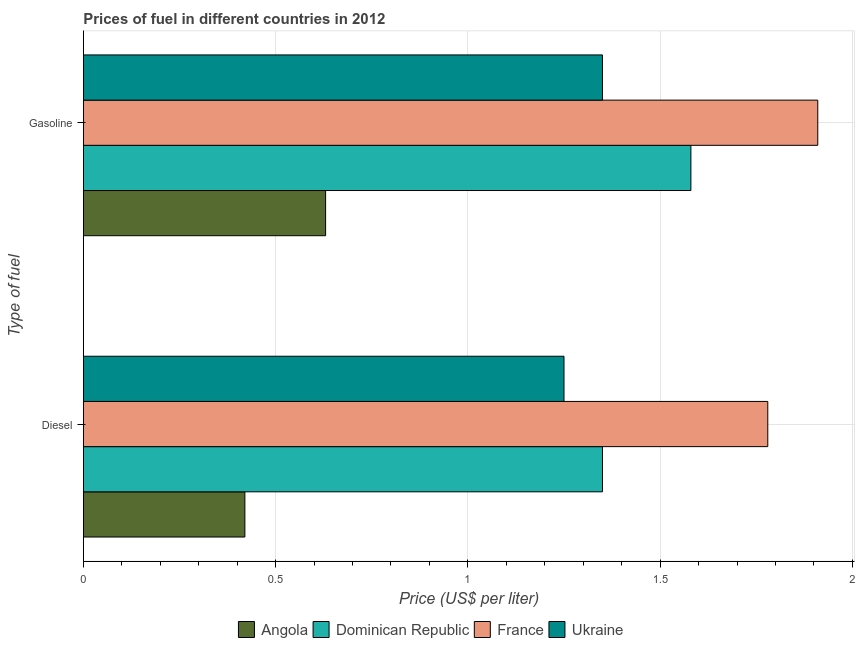How many bars are there on the 1st tick from the bottom?
Provide a short and direct response. 4. What is the label of the 2nd group of bars from the top?
Keep it short and to the point. Diesel. What is the diesel price in Dominican Republic?
Offer a very short reply. 1.35. Across all countries, what is the maximum gasoline price?
Give a very brief answer. 1.91. Across all countries, what is the minimum diesel price?
Provide a short and direct response. 0.42. In which country was the diesel price maximum?
Give a very brief answer. France. In which country was the diesel price minimum?
Give a very brief answer. Angola. What is the difference between the gasoline price in Ukraine and that in France?
Keep it short and to the point. -0.56. What is the difference between the diesel price in France and the gasoline price in Dominican Republic?
Provide a short and direct response. 0.2. What is the difference between the diesel price and gasoline price in France?
Your answer should be very brief. -0.13. In how many countries, is the diesel price greater than 1.4 US$ per litre?
Your answer should be very brief. 1. Is the diesel price in France less than that in Dominican Republic?
Provide a short and direct response. No. What does the 4th bar from the top in Diesel represents?
Your response must be concise. Angola. What does the 4th bar from the bottom in Diesel represents?
Make the answer very short. Ukraine. Are the values on the major ticks of X-axis written in scientific E-notation?
Ensure brevity in your answer.  No. Does the graph contain any zero values?
Give a very brief answer. No. Does the graph contain grids?
Provide a succinct answer. Yes. What is the title of the graph?
Offer a terse response. Prices of fuel in different countries in 2012. What is the label or title of the X-axis?
Provide a succinct answer. Price (US$ per liter). What is the label or title of the Y-axis?
Provide a succinct answer. Type of fuel. What is the Price (US$ per liter) in Angola in Diesel?
Ensure brevity in your answer.  0.42. What is the Price (US$ per liter) in Dominican Republic in Diesel?
Your response must be concise. 1.35. What is the Price (US$ per liter) of France in Diesel?
Offer a terse response. 1.78. What is the Price (US$ per liter) of Angola in Gasoline?
Offer a terse response. 0.63. What is the Price (US$ per liter) in Dominican Republic in Gasoline?
Your response must be concise. 1.58. What is the Price (US$ per liter) of France in Gasoline?
Provide a succinct answer. 1.91. What is the Price (US$ per liter) of Ukraine in Gasoline?
Provide a short and direct response. 1.35. Across all Type of fuel, what is the maximum Price (US$ per liter) in Angola?
Offer a very short reply. 0.63. Across all Type of fuel, what is the maximum Price (US$ per liter) of Dominican Republic?
Your answer should be compact. 1.58. Across all Type of fuel, what is the maximum Price (US$ per liter) of France?
Offer a very short reply. 1.91. Across all Type of fuel, what is the maximum Price (US$ per liter) in Ukraine?
Your answer should be compact. 1.35. Across all Type of fuel, what is the minimum Price (US$ per liter) of Angola?
Give a very brief answer. 0.42. Across all Type of fuel, what is the minimum Price (US$ per liter) in Dominican Republic?
Offer a very short reply. 1.35. Across all Type of fuel, what is the minimum Price (US$ per liter) in France?
Offer a terse response. 1.78. What is the total Price (US$ per liter) in Dominican Republic in the graph?
Provide a succinct answer. 2.93. What is the total Price (US$ per liter) in France in the graph?
Offer a very short reply. 3.69. What is the total Price (US$ per liter) in Ukraine in the graph?
Make the answer very short. 2.6. What is the difference between the Price (US$ per liter) of Angola in Diesel and that in Gasoline?
Provide a succinct answer. -0.21. What is the difference between the Price (US$ per liter) of Dominican Republic in Diesel and that in Gasoline?
Provide a succinct answer. -0.23. What is the difference between the Price (US$ per liter) of France in Diesel and that in Gasoline?
Offer a very short reply. -0.13. What is the difference between the Price (US$ per liter) in Ukraine in Diesel and that in Gasoline?
Provide a succinct answer. -0.1. What is the difference between the Price (US$ per liter) in Angola in Diesel and the Price (US$ per liter) in Dominican Republic in Gasoline?
Provide a short and direct response. -1.16. What is the difference between the Price (US$ per liter) of Angola in Diesel and the Price (US$ per liter) of France in Gasoline?
Keep it short and to the point. -1.49. What is the difference between the Price (US$ per liter) in Angola in Diesel and the Price (US$ per liter) in Ukraine in Gasoline?
Your answer should be very brief. -0.93. What is the difference between the Price (US$ per liter) of Dominican Republic in Diesel and the Price (US$ per liter) of France in Gasoline?
Your response must be concise. -0.56. What is the difference between the Price (US$ per liter) of Dominican Republic in Diesel and the Price (US$ per liter) of Ukraine in Gasoline?
Offer a terse response. 0. What is the difference between the Price (US$ per liter) of France in Diesel and the Price (US$ per liter) of Ukraine in Gasoline?
Keep it short and to the point. 0.43. What is the average Price (US$ per liter) of Angola per Type of fuel?
Your answer should be compact. 0.53. What is the average Price (US$ per liter) in Dominican Republic per Type of fuel?
Keep it short and to the point. 1.47. What is the average Price (US$ per liter) of France per Type of fuel?
Offer a terse response. 1.84. What is the average Price (US$ per liter) of Ukraine per Type of fuel?
Your answer should be compact. 1.3. What is the difference between the Price (US$ per liter) of Angola and Price (US$ per liter) of Dominican Republic in Diesel?
Provide a short and direct response. -0.93. What is the difference between the Price (US$ per liter) in Angola and Price (US$ per liter) in France in Diesel?
Your answer should be compact. -1.36. What is the difference between the Price (US$ per liter) in Angola and Price (US$ per liter) in Ukraine in Diesel?
Offer a terse response. -0.83. What is the difference between the Price (US$ per liter) in Dominican Republic and Price (US$ per liter) in France in Diesel?
Provide a succinct answer. -0.43. What is the difference between the Price (US$ per liter) in France and Price (US$ per liter) in Ukraine in Diesel?
Your response must be concise. 0.53. What is the difference between the Price (US$ per liter) in Angola and Price (US$ per liter) in Dominican Republic in Gasoline?
Keep it short and to the point. -0.95. What is the difference between the Price (US$ per liter) of Angola and Price (US$ per liter) of France in Gasoline?
Provide a short and direct response. -1.28. What is the difference between the Price (US$ per liter) in Angola and Price (US$ per liter) in Ukraine in Gasoline?
Make the answer very short. -0.72. What is the difference between the Price (US$ per liter) of Dominican Republic and Price (US$ per liter) of France in Gasoline?
Your answer should be compact. -0.33. What is the difference between the Price (US$ per liter) of Dominican Republic and Price (US$ per liter) of Ukraine in Gasoline?
Provide a short and direct response. 0.23. What is the difference between the Price (US$ per liter) of France and Price (US$ per liter) of Ukraine in Gasoline?
Offer a very short reply. 0.56. What is the ratio of the Price (US$ per liter) of Angola in Diesel to that in Gasoline?
Provide a short and direct response. 0.67. What is the ratio of the Price (US$ per liter) of Dominican Republic in Diesel to that in Gasoline?
Offer a terse response. 0.85. What is the ratio of the Price (US$ per liter) of France in Diesel to that in Gasoline?
Make the answer very short. 0.93. What is the ratio of the Price (US$ per liter) of Ukraine in Diesel to that in Gasoline?
Provide a short and direct response. 0.93. What is the difference between the highest and the second highest Price (US$ per liter) of Angola?
Offer a terse response. 0.21. What is the difference between the highest and the second highest Price (US$ per liter) in Dominican Republic?
Ensure brevity in your answer.  0.23. What is the difference between the highest and the second highest Price (US$ per liter) in France?
Ensure brevity in your answer.  0.13. What is the difference between the highest and the lowest Price (US$ per liter) of Angola?
Offer a very short reply. 0.21. What is the difference between the highest and the lowest Price (US$ per liter) of Dominican Republic?
Your answer should be compact. 0.23. What is the difference between the highest and the lowest Price (US$ per liter) in France?
Your response must be concise. 0.13. What is the difference between the highest and the lowest Price (US$ per liter) of Ukraine?
Your answer should be compact. 0.1. 